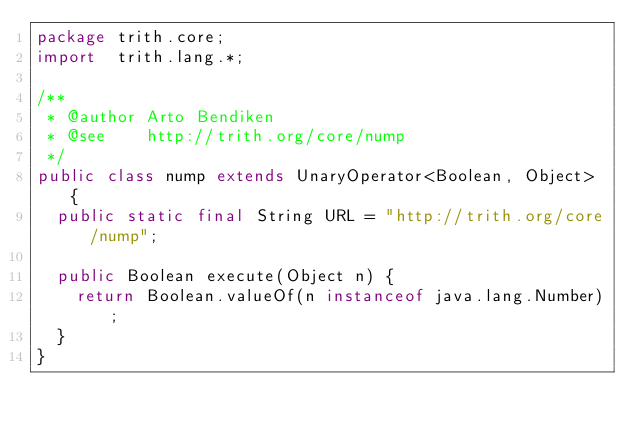Convert code to text. <code><loc_0><loc_0><loc_500><loc_500><_Java_>package trith.core;
import  trith.lang.*;

/**
 * @author Arto Bendiken
 * @see    http://trith.org/core/nump
 */
public class nump extends UnaryOperator<Boolean, Object> {
  public static final String URL = "http://trith.org/core/nump";

  public Boolean execute(Object n) {
    return Boolean.valueOf(n instanceof java.lang.Number);
  }
}
</code> 